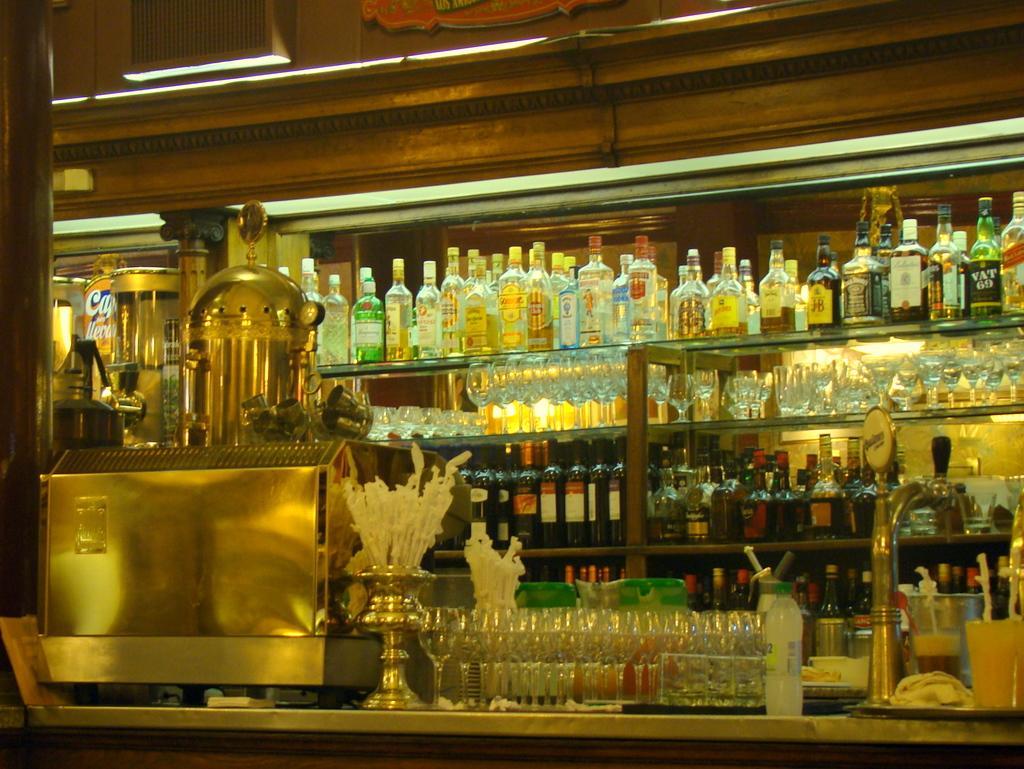Could you give a brief overview of what you see in this image? There are racks. And in the racks there are bottles and wine glasses are kept. 